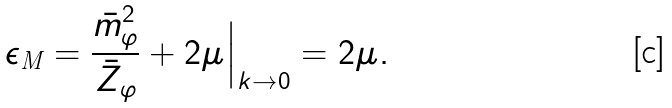<formula> <loc_0><loc_0><loc_500><loc_500>\epsilon _ { \text {M} } = \frac { \bar { m } _ { \varphi } ^ { 2 } } { \bar { Z } _ { \varphi } } + 2 \mu \Big | _ { k \to 0 } = 2 \mu .</formula> 